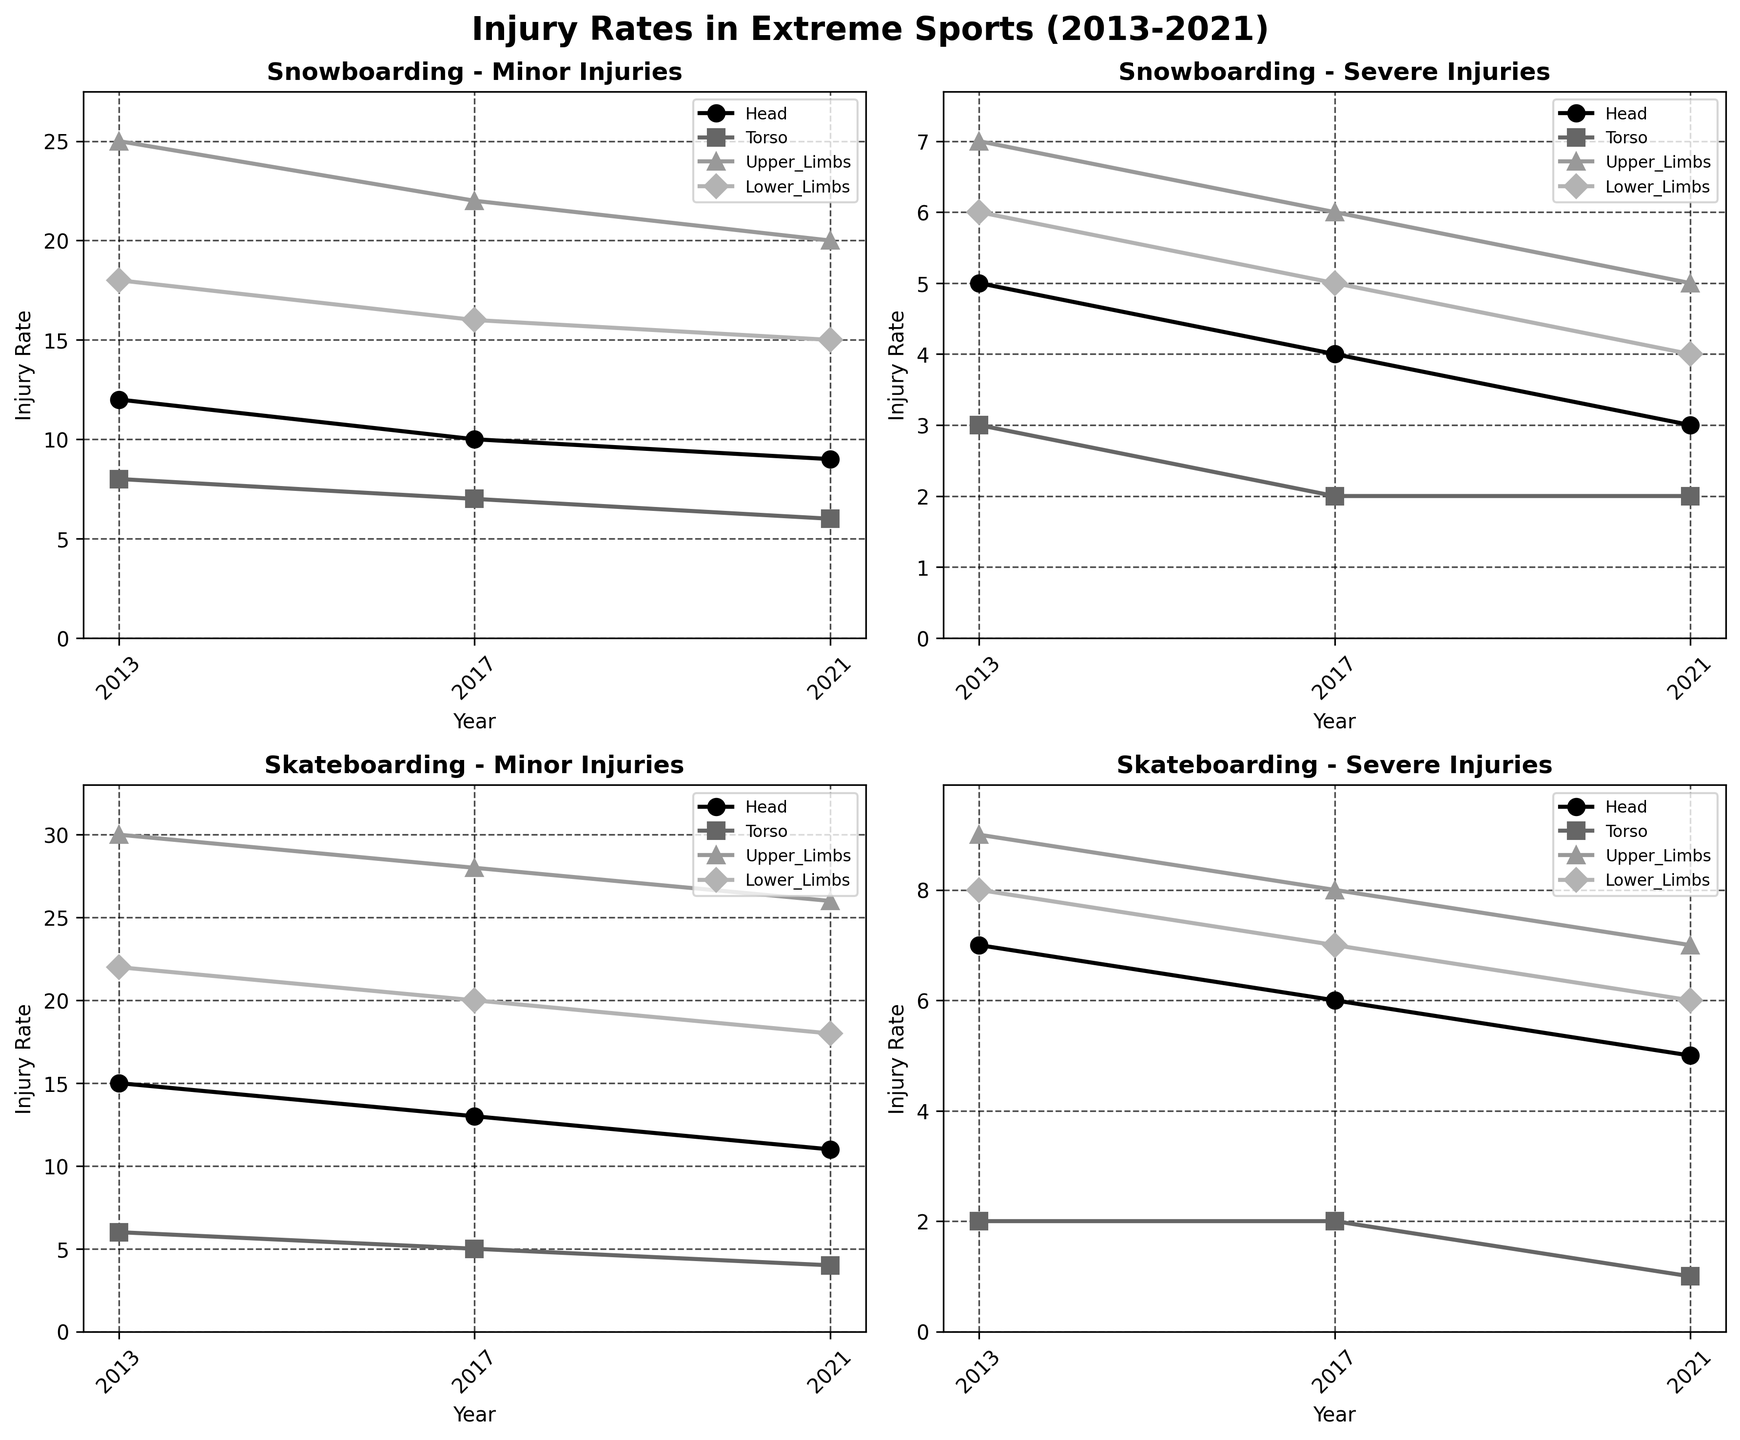What is the title of the figure? The title of the figure is displayed at the top and it summarizes the overall theme of the visual representation.
Answer: Injury Rates in Extreme Sports (2013-2021) How many subplots are there in the figure? Count each individual plot within the grid to determine the total number. In this case, there are four plots arranged in a 2x2 grid.
Answer: 4 Which body part has the highest number of minor injuries in skateboarding in 2013? Refer to the subplot for Skateboarding - Minor Injuries and identify the bar with the highest value in 2013.
Answer: Upper Limbs How did the number of severe head injuries in snowboarding change from 2013 to 2021? Look at the plot for Snowboarding - Severe Injuries and compare the data points for head injuries in the years 2013 and 2021.
Answer: Decreased from 5 to 3 Which severity level has a lower injury rate for torso injuries in skateboarding in 2017: Minor or Severe? Compare the value for torso injuries in the subplots for Skateboarding in 2017 under Minor and Severe injury rates.
Answer: Severe Did the rate of lower limb injuries in snowboarding increase or decrease from 2017 to 2021 for minor injuries? Look at the plot for Snowboarding - Minor Injuries and compare the values for lower limb injuries in 2017 and 2021.
Answer: Decrease What is the average number of upper limb injuries for severe skateboarding injuries across all the years? Sum the upper limb injuries for Skateboarding - Severe Injuries across 2013, 2017, and 2021 and then divide by the number of years (3).
Answer: (9 + 8 + 7) / 3 = 8 Which sport and injury severity combination has the highest injury rate for torso injuries in 2021? Look at the data points for torso injuries in both sports under both severity levels in 2021 and identify the highest value among the four categories.
Answer: Snowboarding - Minor How do upper limb injuries compare between minor and severe injuries in snowboarding in 2017? Compare the values of upper limb injuries in the subplot for Snowboarding for Minor and Severe injuries in 2017.
Answer: Minor injuries have higher rates What trend can be observed in the number of head injuries for skateboarding from 2013 to 2021 for minor injuries? Examine the Skateboarding - Minor Injuries subplot and analyze how the number of head injuries changes over the years from 2013 to 2021.
Answer: Decreasing trend 